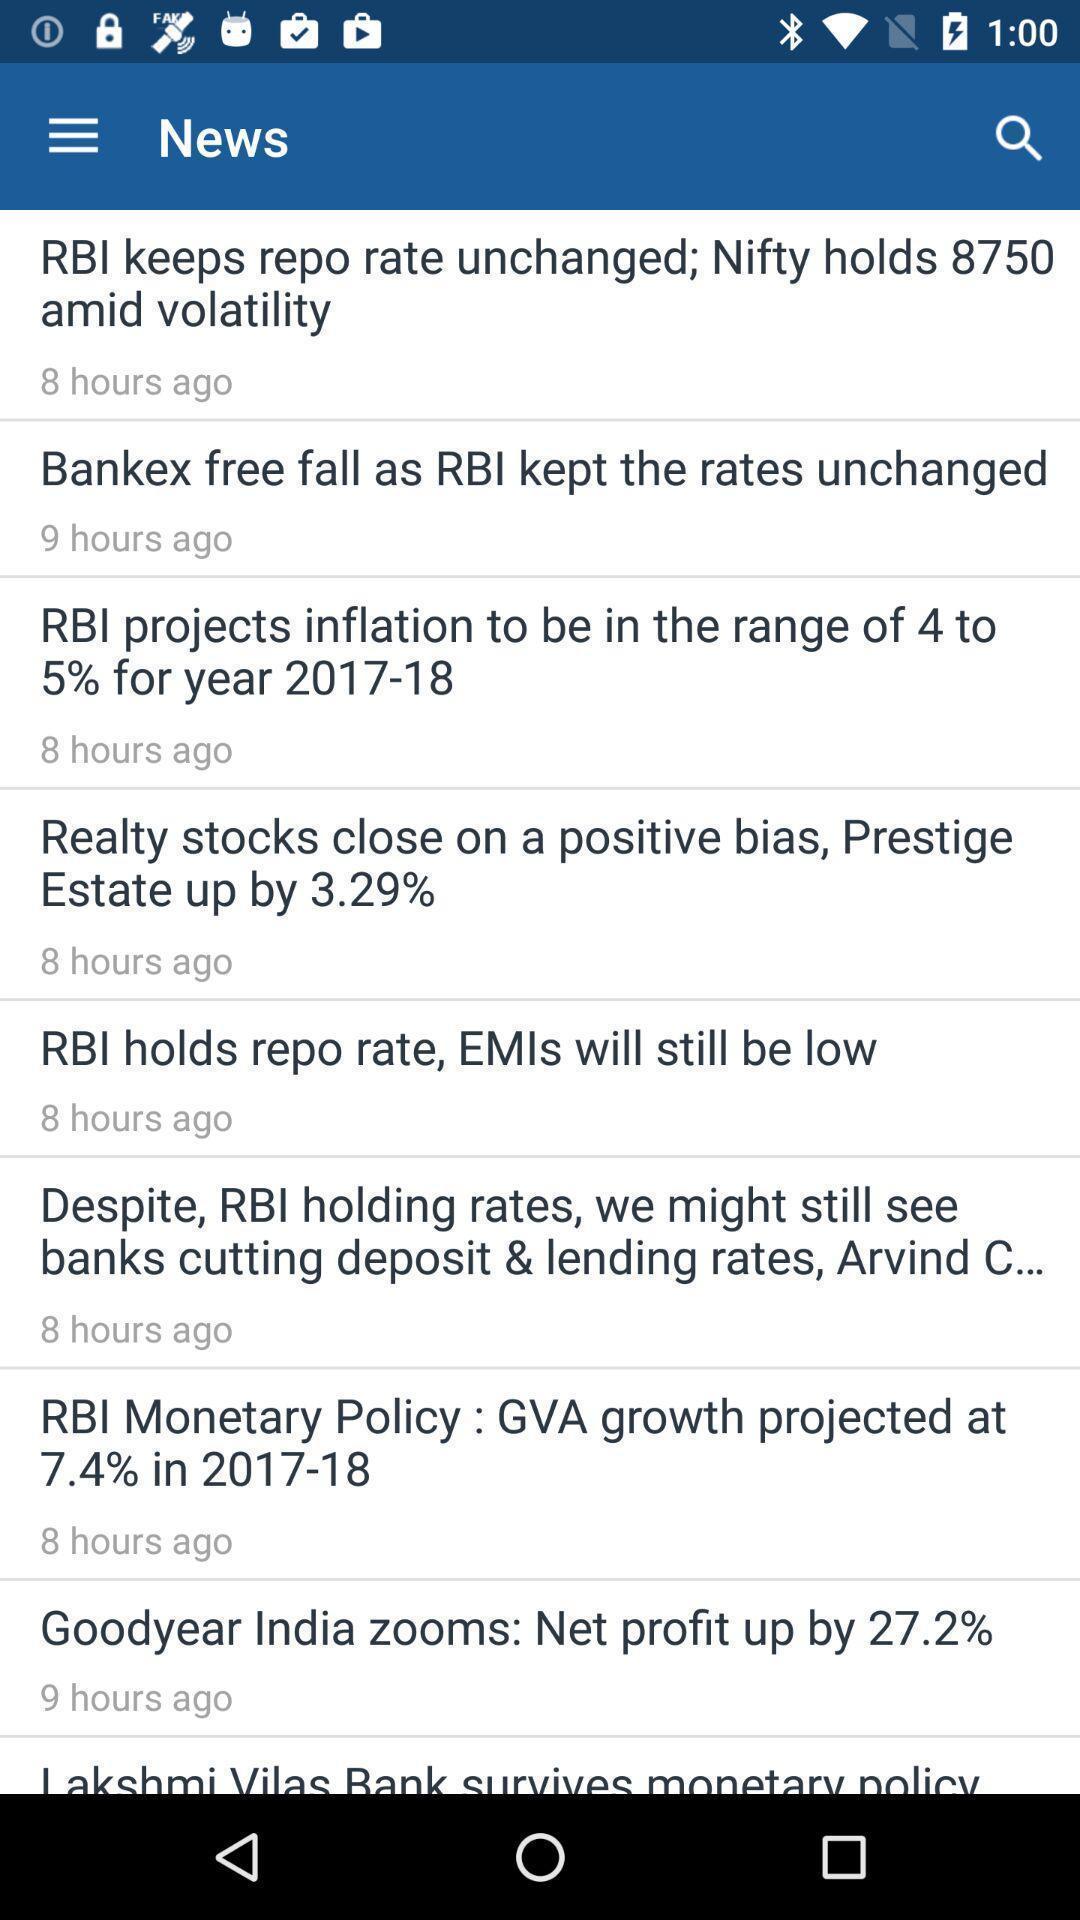Explain what's happening in this screen capture. Page showing list of news updates in a trading app. 